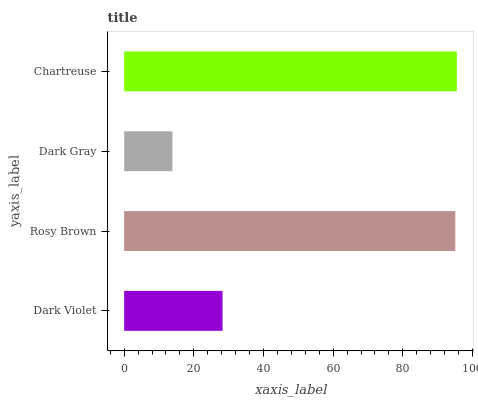Is Dark Gray the minimum?
Answer yes or no. Yes. Is Chartreuse the maximum?
Answer yes or no. Yes. Is Rosy Brown the minimum?
Answer yes or no. No. Is Rosy Brown the maximum?
Answer yes or no. No. Is Rosy Brown greater than Dark Violet?
Answer yes or no. Yes. Is Dark Violet less than Rosy Brown?
Answer yes or no. Yes. Is Dark Violet greater than Rosy Brown?
Answer yes or no. No. Is Rosy Brown less than Dark Violet?
Answer yes or no. No. Is Rosy Brown the high median?
Answer yes or no. Yes. Is Dark Violet the low median?
Answer yes or no. Yes. Is Dark Gray the high median?
Answer yes or no. No. Is Rosy Brown the low median?
Answer yes or no. No. 